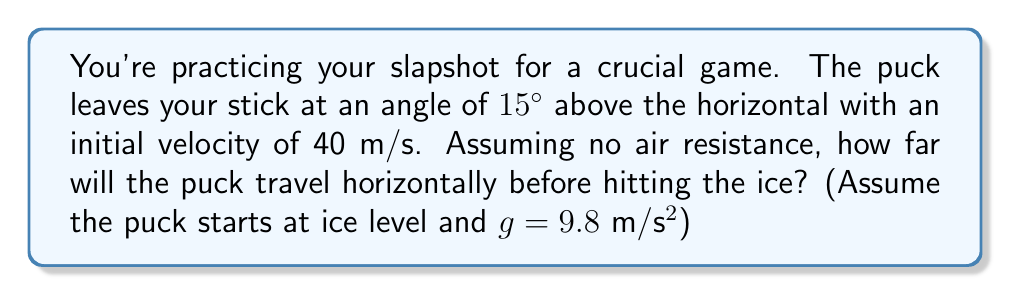What is the answer to this math problem? Let's approach this step-by-step using projectile motion equations:

1) First, we need to break down the initial velocity into its horizontal and vertical components:

   $v_{0x} = v_0 \cos{\theta} = 40 \cos{15°} = 38.64$ m/s
   $v_{0y} = v_0 \sin{\theta} = 40 \sin{15°} = 10.36$ m/s

2) The time the puck is in the air can be found using the vertical motion equation:

   $y = v_{0y}t - \frac{1}{2}gt^2$

   At the point where the puck hits the ice, y = 0:

   $0 = 10.36t - \frac{1}{2}(9.8)t^2$

3) Solving this quadratic equation:

   $4.9t^2 - 10.36t = 0$
   $t(4.9t - 10.36) = 0$
   $t = 0$ or $t = 2.11$ seconds

   We take the non-zero solution, t = 2.11 seconds.

4) Now that we know the time of flight, we can use the horizontal motion equation to find the distance:

   $x = v_{0x}t$
   $x = 38.64 * 2.11 = 81.53$ meters

Therefore, the puck will travel approximately 81.53 meters horizontally before hitting the ice.
Answer: 81.53 m 